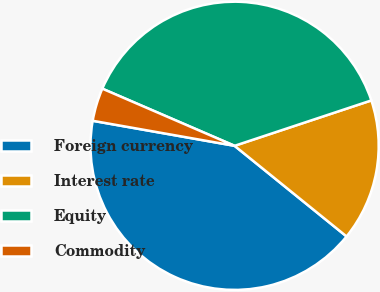Convert chart. <chart><loc_0><loc_0><loc_500><loc_500><pie_chart><fcel>Foreign currency<fcel>Interest rate<fcel>Equity<fcel>Commodity<nl><fcel>41.95%<fcel>15.93%<fcel>38.41%<fcel>3.71%<nl></chart> 